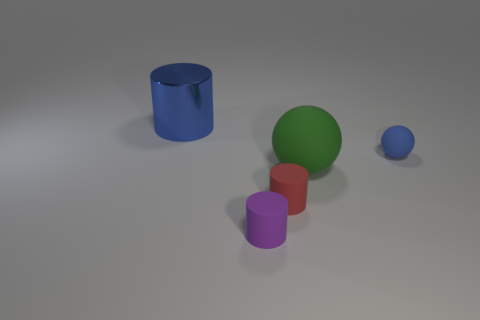Could you describe the arrangement of the items in the image? Certainly, the objects are arranged on a flat surface with even lighting. From left to right, there's a large blue cylinder, a medium-sized green sphere, a small red cylinder, and a small blue sphere, creating a descending order in size and introducing a sense of rhythm to the composition. 